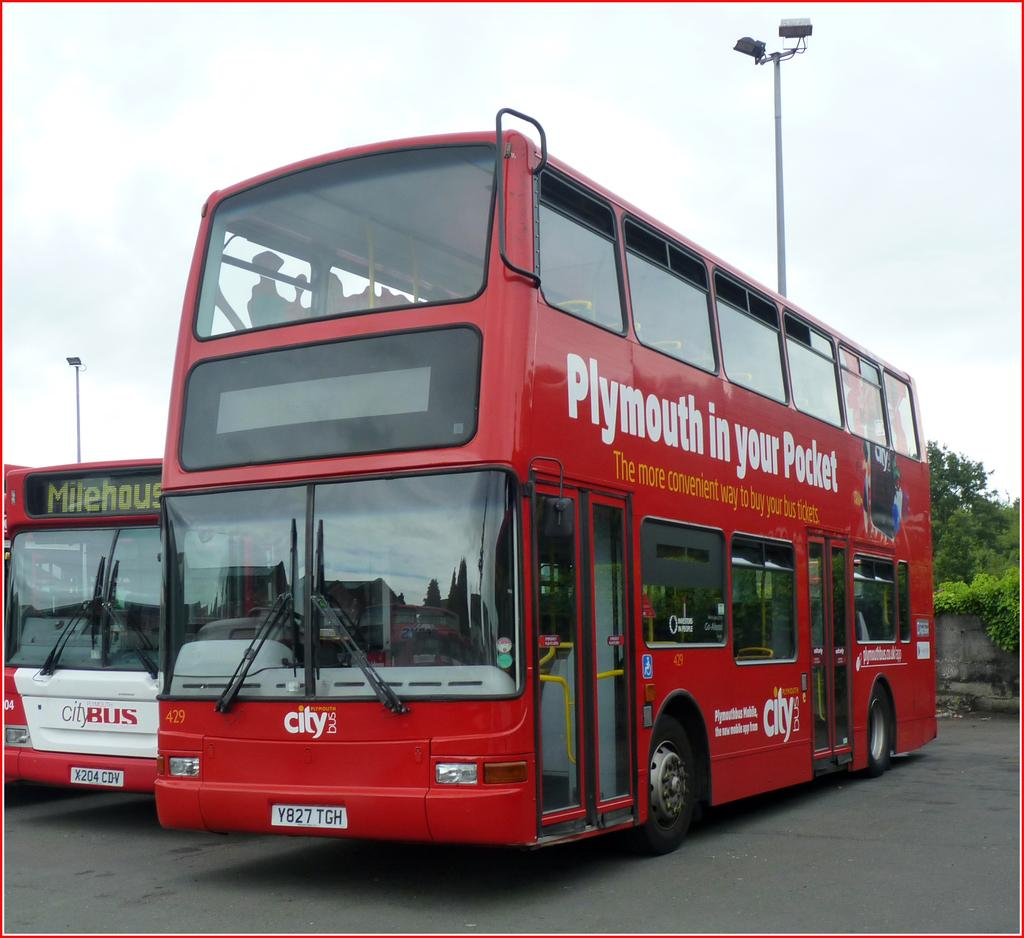<image>
Provide a brief description of the given image. A double decker bus has an advertisement on the side which reads Plymouth in your pocket. 